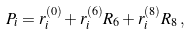Convert formula to latex. <formula><loc_0><loc_0><loc_500><loc_500>P _ { i } = r _ { i } ^ { ( 0 ) } + r _ { i } ^ { ( 6 ) } R _ { 6 } + r _ { i } ^ { ( 8 ) } R _ { 8 } \, ,</formula> 